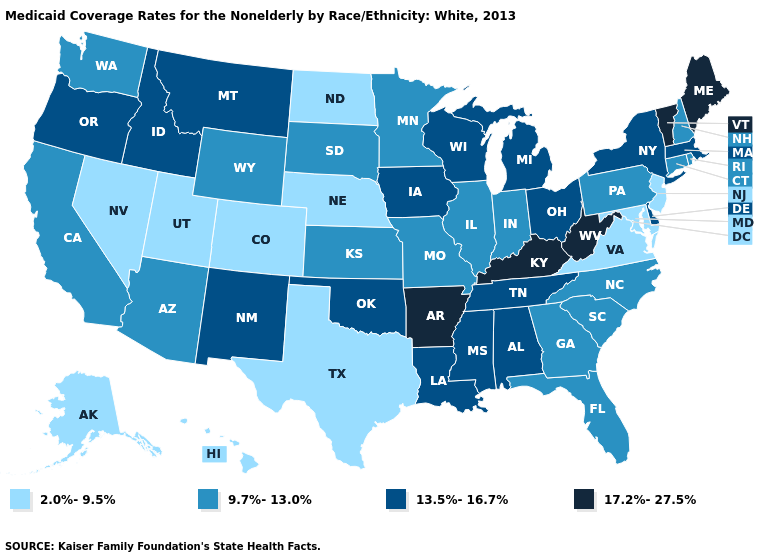Name the states that have a value in the range 9.7%-13.0%?
Quick response, please. Arizona, California, Connecticut, Florida, Georgia, Illinois, Indiana, Kansas, Minnesota, Missouri, New Hampshire, North Carolina, Pennsylvania, Rhode Island, South Carolina, South Dakota, Washington, Wyoming. What is the value of Minnesota?
Be succinct. 9.7%-13.0%. What is the value of New York?
Quick response, please. 13.5%-16.7%. What is the value of Tennessee?
Answer briefly. 13.5%-16.7%. What is the value of New York?
Write a very short answer. 13.5%-16.7%. Among the states that border New Mexico , which have the lowest value?
Quick response, please. Colorado, Texas, Utah. Which states hav the highest value in the Northeast?
Concise answer only. Maine, Vermont. Which states have the lowest value in the MidWest?
Be succinct. Nebraska, North Dakota. What is the value of Indiana?
Concise answer only. 9.7%-13.0%. What is the highest value in the USA?
Quick response, please. 17.2%-27.5%. Does Pennsylvania have the lowest value in the USA?
Answer briefly. No. Does the map have missing data?
Be succinct. No. What is the highest value in the USA?
Short answer required. 17.2%-27.5%. What is the value of Mississippi?
Be succinct. 13.5%-16.7%. Which states have the lowest value in the MidWest?
Answer briefly. Nebraska, North Dakota. 